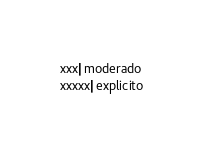<code> <loc_0><loc_0><loc_500><loc_500><_SQL_>xxx|moderado
xxxxx|explicito</code> 